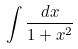Convert formula to latex. <formula><loc_0><loc_0><loc_500><loc_500>\int \frac { d x } { 1 + x ^ { 2 } }</formula> 